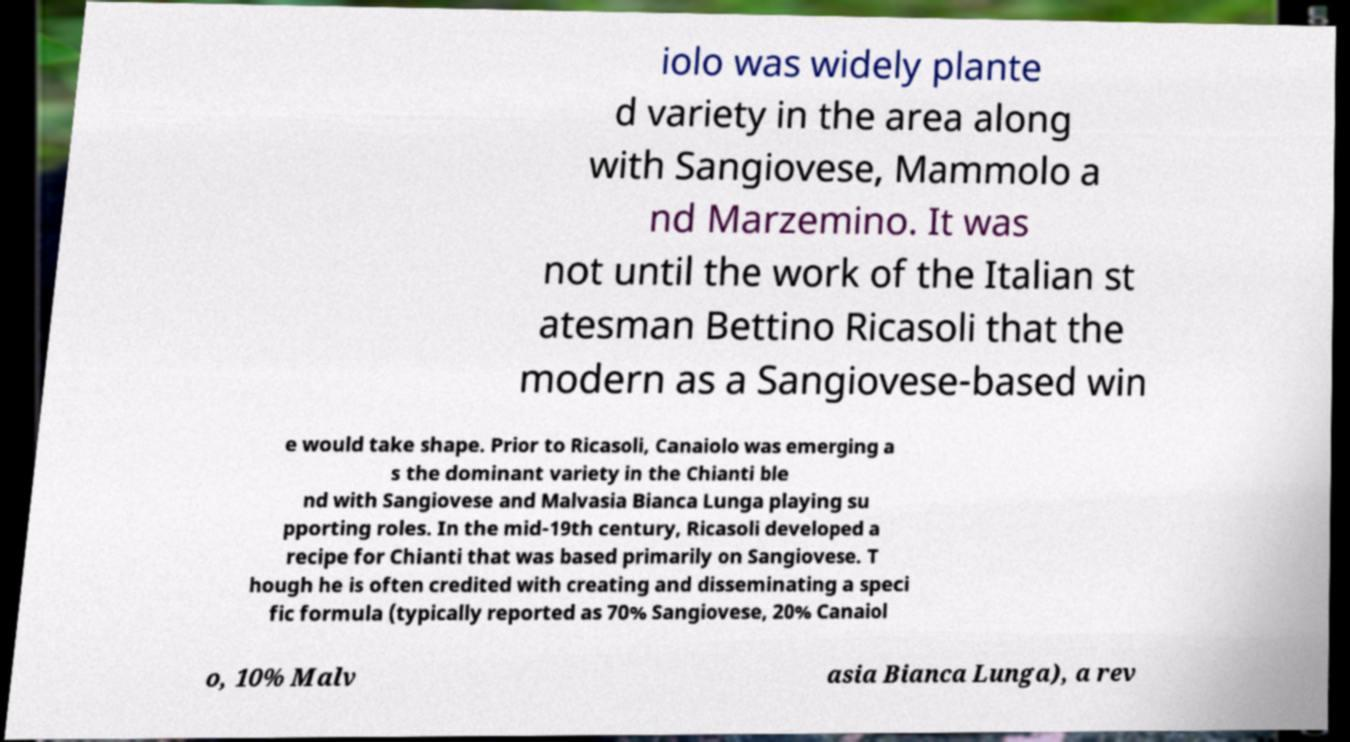Could you assist in decoding the text presented in this image and type it out clearly? iolo was widely plante d variety in the area along with Sangiovese, Mammolo a nd Marzemino. It was not until the work of the Italian st atesman Bettino Ricasoli that the modern as a Sangiovese-based win e would take shape. Prior to Ricasoli, Canaiolo was emerging a s the dominant variety in the Chianti ble nd with Sangiovese and Malvasia Bianca Lunga playing su pporting roles. In the mid-19th century, Ricasoli developed a recipe for Chianti that was based primarily on Sangiovese. T hough he is often credited with creating and disseminating a speci fic formula (typically reported as 70% Sangiovese, 20% Canaiol o, 10% Malv asia Bianca Lunga), a rev 